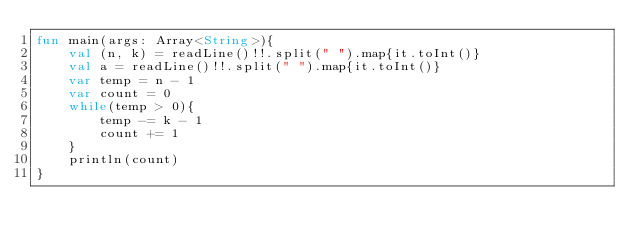Convert code to text. <code><loc_0><loc_0><loc_500><loc_500><_Kotlin_>fun main(args: Array<String>){
    val (n, k) = readLine()!!.split(" ").map{it.toInt()}
    val a = readLine()!!.split(" ").map{it.toInt()}
    var temp = n - 1
    var count = 0
    while(temp > 0){
        temp -= k - 1
        count += 1
    }
    println(count)
}</code> 